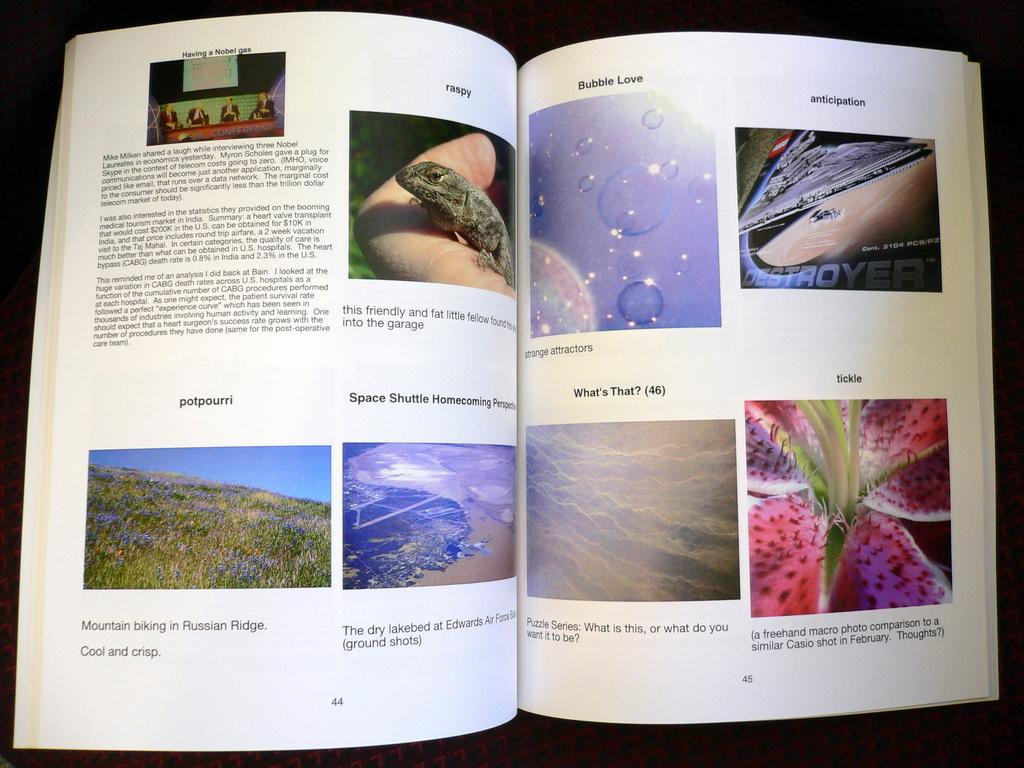What is the main object in the image? There is a book in the image. What type of content is inside the book? The book contains images of grass and a reptile. Is there any text present on the book? Yes, there is text written on the book. Can you tell me how many moms are depicted in the book? There is no mention of moms in the provided facts, as the book contains images of grass and a reptile. 